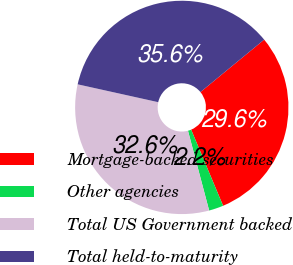<chart> <loc_0><loc_0><loc_500><loc_500><pie_chart><fcel>Mortgage-backed securities<fcel>Other agencies<fcel>Total US Government backed<fcel>Total held-to-maturity<nl><fcel>29.63%<fcel>2.2%<fcel>32.6%<fcel>35.57%<nl></chart> 